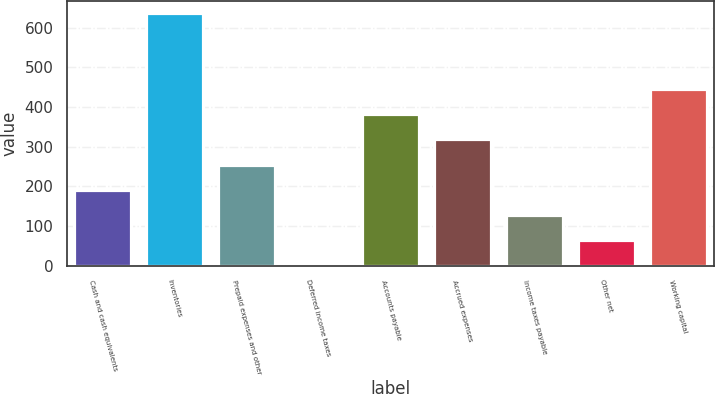Convert chart to OTSL. <chart><loc_0><loc_0><loc_500><loc_500><bar_chart><fcel>Cash and cash equivalents<fcel>Inventories<fcel>Prepaid expenses and other<fcel>Deferred income taxes<fcel>Accounts payable<fcel>Accrued expenses<fcel>Income taxes payable<fcel>Other net<fcel>Working capital<nl><fcel>191.01<fcel>636<fcel>254.58<fcel>0.3<fcel>381.72<fcel>318.15<fcel>127.44<fcel>63.87<fcel>445.29<nl></chart> 